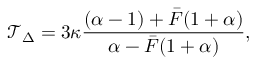Convert formula to latex. <formula><loc_0><loc_0><loc_500><loc_500>\mathcal { T } _ { \Delta } = 3 \kappa \frac { ( \alpha - 1 ) + \bar { F } ( 1 + \alpha ) } { \alpha - \bar { F } ( 1 + \alpha ) } ,</formula> 